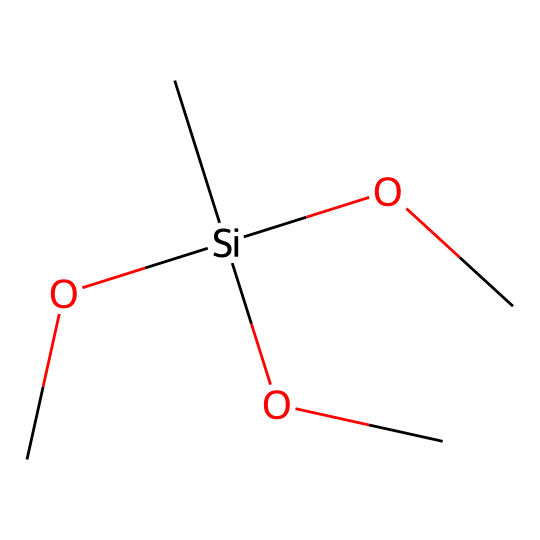What is the core atom in this silane structure? The central atom in this chemical is silicon, which is represented by 'Si' in the SMILES notation.
Answer: silicon How many carbon atoms are present in this chemical? By analyzing the SMILES, we can see that there are three 'C' symbols, indicating three carbon atoms in the structure.
Answer: three What is the total number of alkoxy groups in this silane? The presence of 'OC' three times in the SMILES indicates that there are three alkoxy groups attached to the silicon atom.
Answer: three What type of chemical is this compound classified as? This compound is a silane, indicated by the presence of the silicon atom (Si) and the connecting groups.
Answer: silane What functional groups are present along with the silane? The three alkoxy groups (–OCH3) attached to the silicon are the functional groups present in this silane compound.
Answer: alkoxy groups What is the expected role of this silane in composite materials? Silane coupling agents like this one enhance adhesion between inorganic materials and organic matrices in composites, promoting better mechanical properties.
Answer: adhesion promoter How many total atoms are present in this compound? Counting the atoms from the SMILES notation: 3 Carbons, 1 Silicon, and 9 Oxygens; this totals 13 atoms in this chemical compound.
Answer: thirteen 